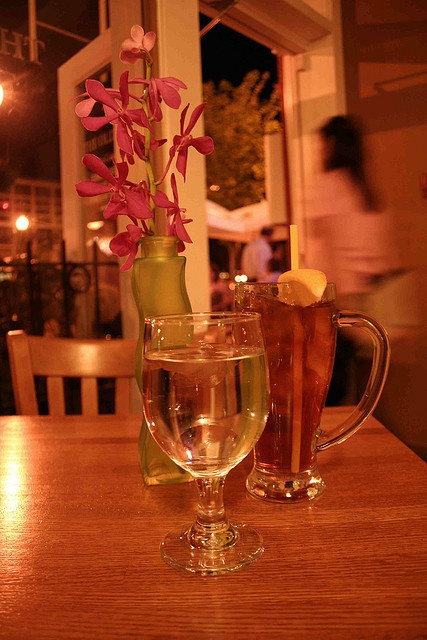Describe the objects in this image and their specific colors. I can see dining table in black, brown, red, and orange tones, wine glass in black, brown, maroon, and red tones, cup in black, maroon, and brown tones, chair in black, brown, and red tones, and vase in black, brown, orange, and maroon tones in this image. 